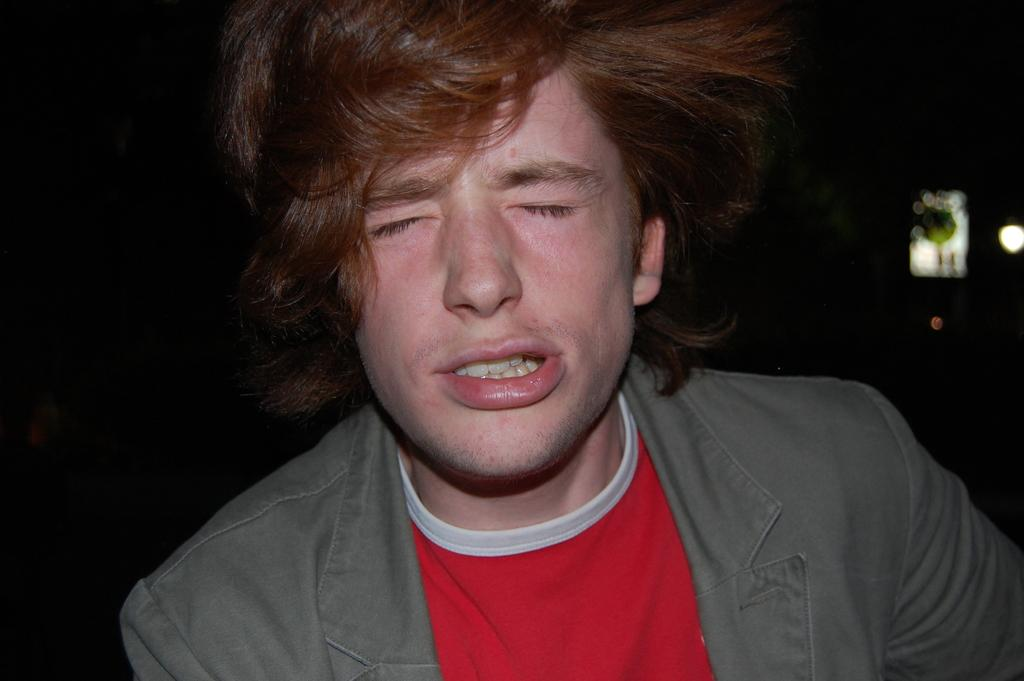Who is present in the image? There is a man in the image. What is the man wearing in the image? The man is wearing a jacket in the image. Can you describe the background of the image? The background of the image is dark. What else can be seen in the image besides the man? Lights are visible in the image. What invention is the man holding in the image? There is no invention visible in the image; the man is simply wearing a jacket and standing in front of a dark background with lights. 